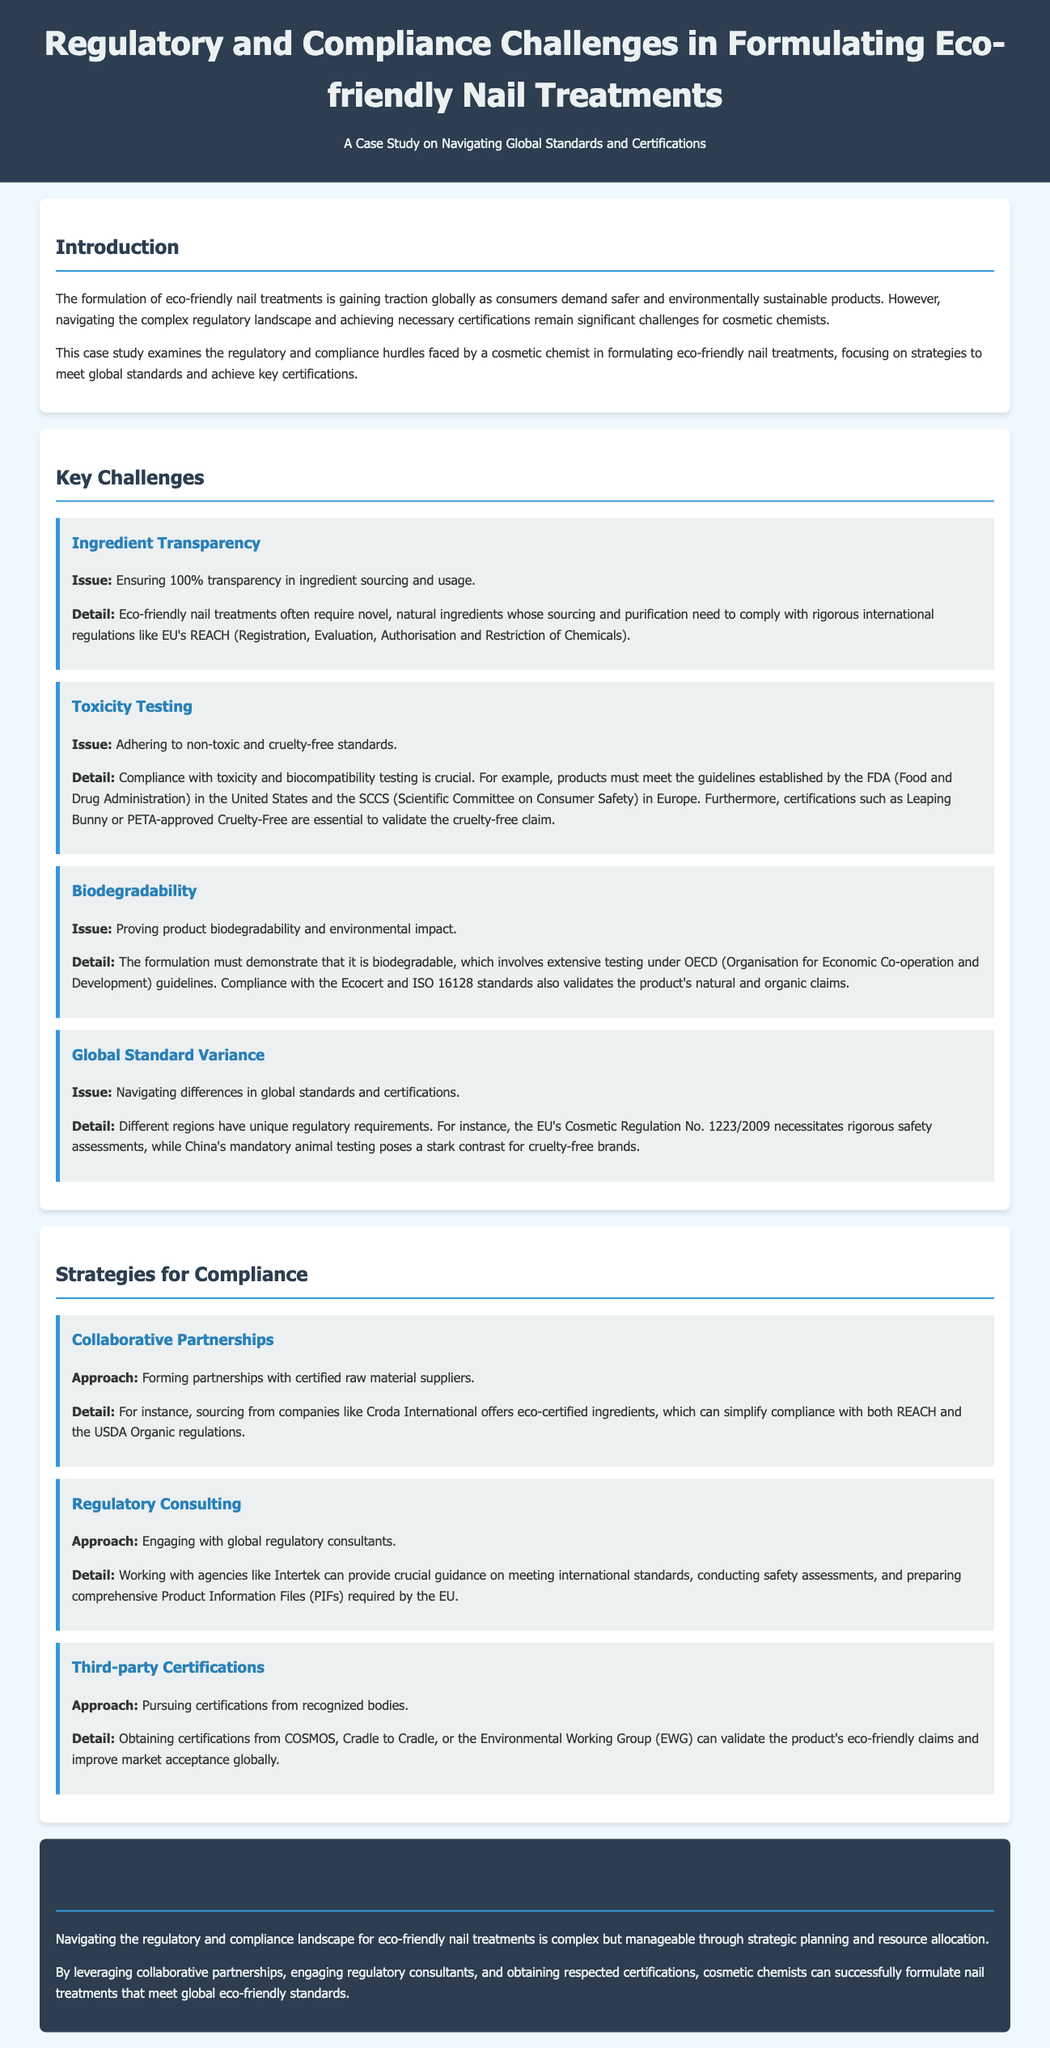What is the main focus of the case study? The case study focuses on navigating global standards and certifications for eco-friendly nail treatments.
Answer: Navigating global standards and certifications What is the first key challenge mentioned? The first key challenge mentioned is about ensuring transparency in ingredient sourcing and usage.
Answer: Ingredient Transparency What certification is mentioned for cruelty-free validation? Certifications like Leaping Bunny or PETA-approved are essential for cruelty-free validation.
Answer: Leaping Bunny or PETA-approved What organization’s guidelines must the formulation comply with for biodegradability testing? The formulation must comply with OECD guidelines for biodegradability testing.
Answer: OECD Which approach involves obtaining certifications from recognized bodies? The approach of seeking third-party certifications involves obtaining recognized certifications.
Answer: Third-party certifications What kind of partnerships are suggested for compliance? Collaborative partnerships with certified raw material suppliers are suggested for compliance.
Answer: Collaborative partnerships How can regulatory consulting assist cosmetic chemists? Regulatory consulting can provide guidance on meeting international standards and preparing Product Information Files.
Answer: Guidance on standards and PIFs What is the conclusion about navigating regulatory challenges? The conclusion emphasizes that the challenges are complex but manageable through strategic planning and resource allocation.
Answer: Complex but manageable What is a suggested source for eco-certified ingredients? Sourcing from companies like Croda International is suggested for eco-certified ingredients.
Answer: Croda International 